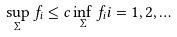Convert formula to latex. <formula><loc_0><loc_0><loc_500><loc_500>\sup _ { \Sigma } f _ { i } \leq c \inf _ { \Sigma } f _ { i } i = 1 , 2 , \dots</formula> 